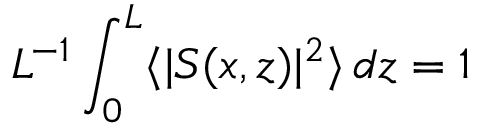Convert formula to latex. <formula><loc_0><loc_0><loc_500><loc_500>L ^ { - 1 } \int _ { 0 } ^ { L } \langle | S ( x , z ) | ^ { 2 } \rangle \, d z = 1</formula> 